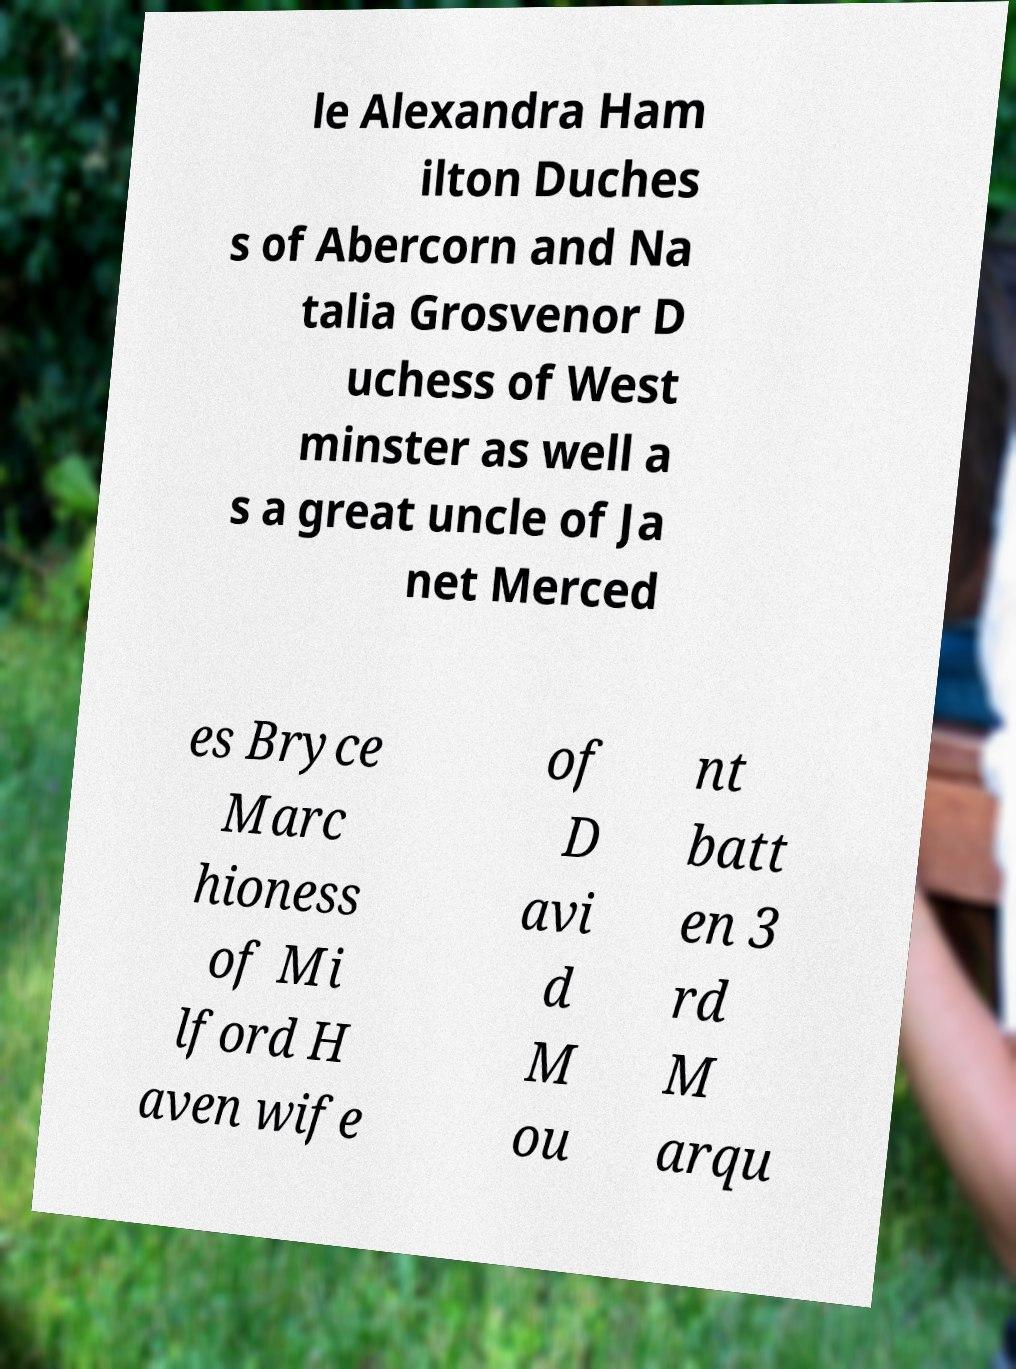Could you extract and type out the text from this image? le Alexandra Ham ilton Duches s of Abercorn and Na talia Grosvenor D uchess of West minster as well a s a great uncle of Ja net Merced es Bryce Marc hioness of Mi lford H aven wife of D avi d M ou nt batt en 3 rd M arqu 